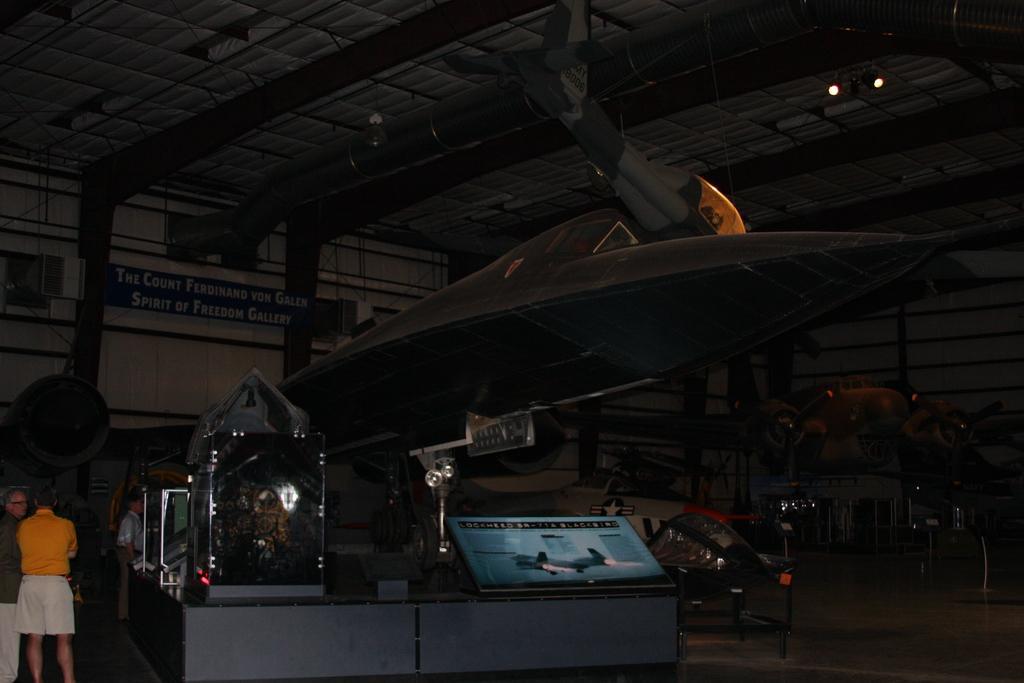Please provide a concise description of this image. In this picture we can see aircraft here, on the left side there are two persons standing, we can see a board here, there are two lights at the top of the picture. 